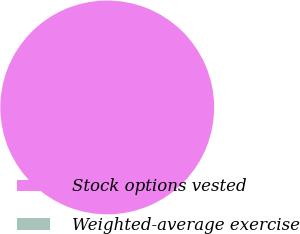Convert chart to OTSL. <chart><loc_0><loc_0><loc_500><loc_500><pie_chart><fcel>Stock options vested<fcel>Weighted-average exercise<nl><fcel>99.99%<fcel>0.01%<nl></chart> 